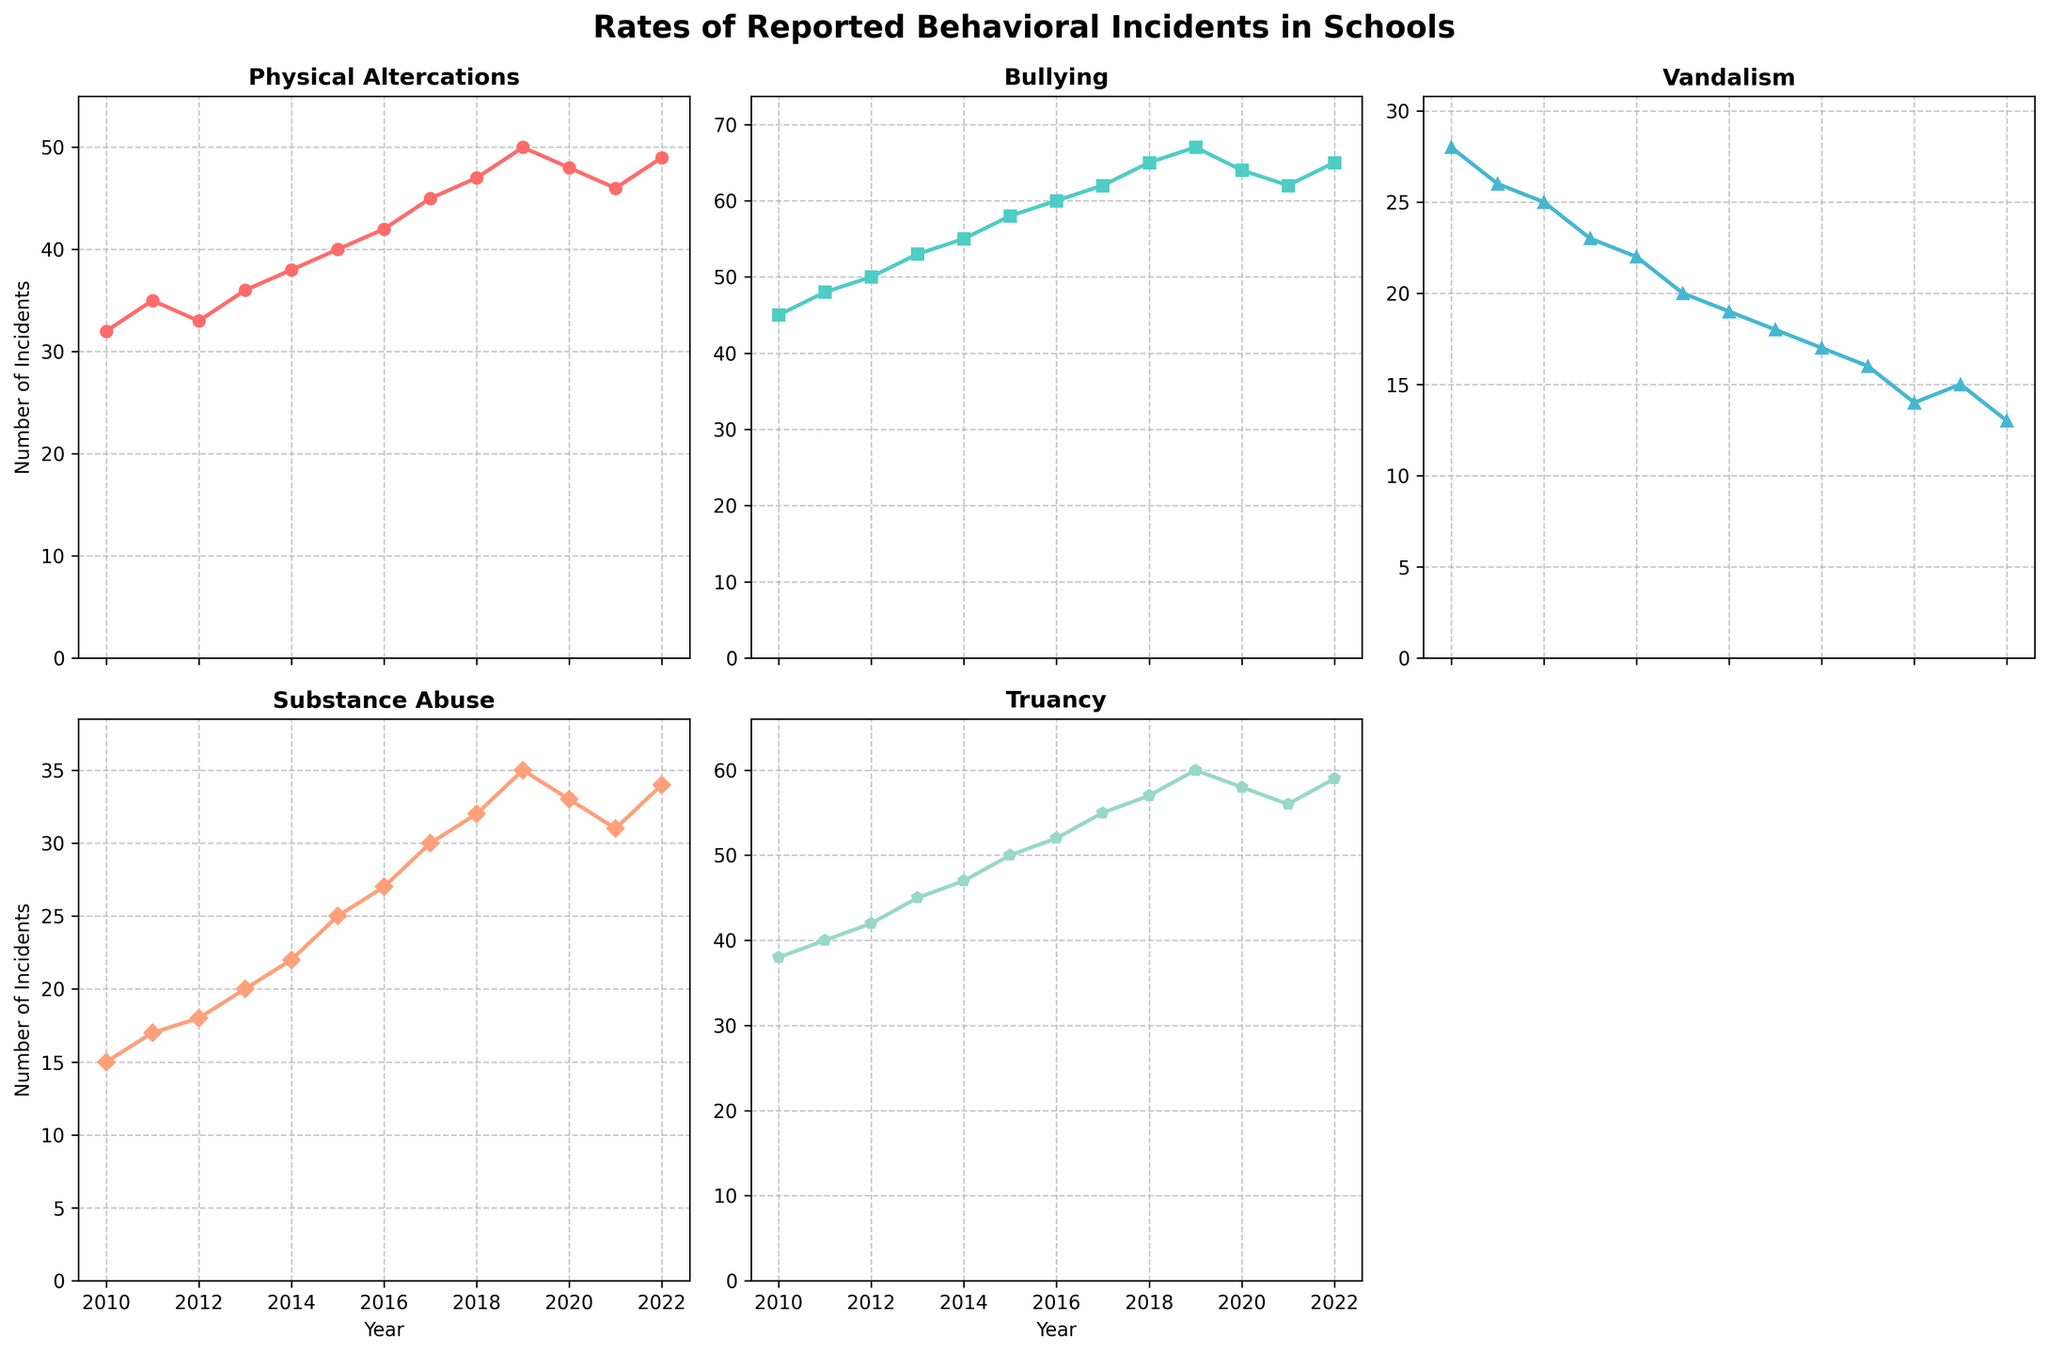What is the average number of bullying incidents reported from 2010 to 2022? To find the average, sum the number of bullying incidents for each year and divide by the number of years. Sum: 45+48+50+53+55+58+60+62+65+67+64+62+65=764. Number of years: 2022-2010+1=13. Average = 764 / 13 ≈ 58.77
Answer: 58.77 In which year were the most vandalism incidents reported? By looking at the Vandalism subplot, identify the highest point on the line. The highest point corresponds to the year 2010 with 28 incidents.
Answer: 2010 Compare the trends in physical altercations and substance abuse from 2010 to 2022. How do they differ? Physical altercations generally increase each year, whereas substance abuse increases until 2019 but slightly decreases or plateaus afterward.
Answer: Physical altercations increase steadily, substance abuse rises then levels off Which type of incident showed the most growth from 2010 to 2022? Calculate the difference between the incidents in 2022 and 2010 for each type. Physical Altercations: 49-32=17, Bullying: 65-45=20, Vandalism: 13-28=-15, Substance Abuse: 34-15=19, Truancy: 59-38=21. Truancy shows the highest growth.
Answer: Truancy Which incident type had the least number of incidents in 2022? By looking at the endpoints of the lines in 2022, the lowest number is 13, which corresponds to Vandalism.
Answer: Vandalism In which year did truancy incidents first exceed 50? By examining the Truancy subplot around the years 2014-2015, it is evident that the first year when incidents exceed 50 is in 2018 with 52 incidents.
Answer: 2018 How did the number of substance abuse incidents change from 2019 to 2022? Identify and subtract the number of substance abuse incidents in 2022 from that in 2019. 2022: 34, 2019: 35. Change = 34-35 = -1, so there is a decrease of 1 incident.
Answer: Decreased by 1 What was the difference between the number of bullying incidents in 2010 and 2015? Subtract the number of bullying incidents in 2010 from the number in 2015. 2015: 58, 2010: 45. Difference = 58-45 = 13.
Answer: 13 Identify the downward trend in any of the incident types. Which types of incidents decreased in number over the given period? Examine the slope of each type of incidents line. Vandalism is the only type that consistently shows a decreasing trend from 28 in 2010 to 13 in 2022.
Answer: Vandalism 